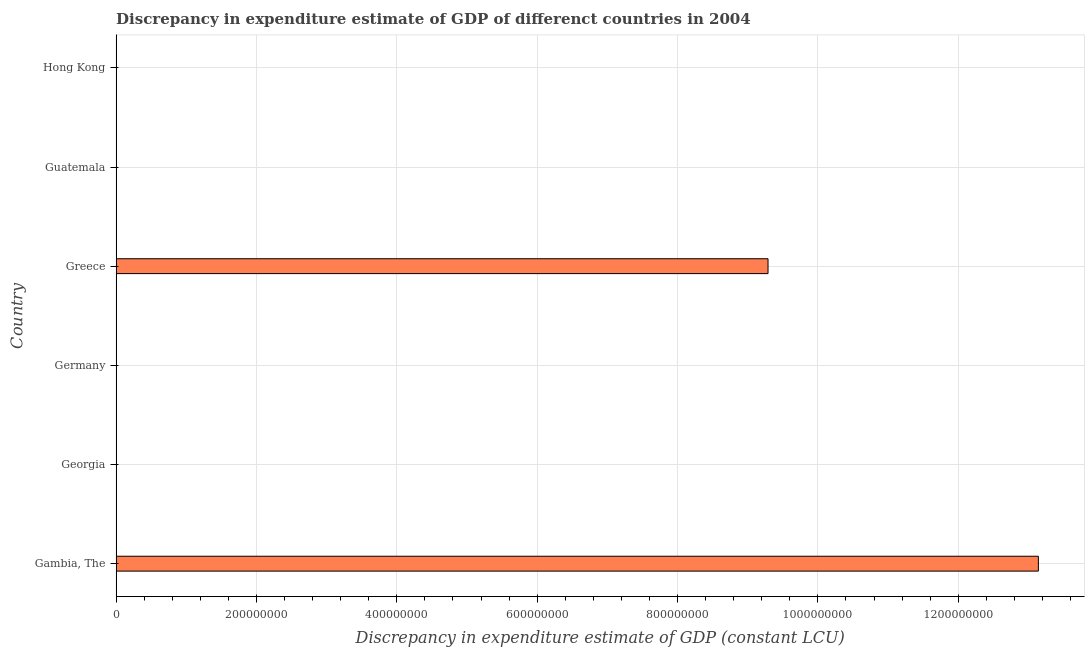Does the graph contain any zero values?
Provide a succinct answer. Yes. What is the title of the graph?
Offer a terse response. Discrepancy in expenditure estimate of GDP of differenct countries in 2004. What is the label or title of the X-axis?
Keep it short and to the point. Discrepancy in expenditure estimate of GDP (constant LCU). What is the label or title of the Y-axis?
Your answer should be very brief. Country. What is the discrepancy in expenditure estimate of gdp in Hong Kong?
Your answer should be very brief. 0. Across all countries, what is the maximum discrepancy in expenditure estimate of gdp?
Make the answer very short. 1.31e+09. In which country was the discrepancy in expenditure estimate of gdp maximum?
Your response must be concise. Gambia, The. What is the sum of the discrepancy in expenditure estimate of gdp?
Your answer should be very brief. 2.24e+09. What is the difference between the discrepancy in expenditure estimate of gdp in Gambia, The and Greece?
Give a very brief answer. 3.85e+08. What is the average discrepancy in expenditure estimate of gdp per country?
Give a very brief answer. 3.74e+08. What is the median discrepancy in expenditure estimate of gdp?
Make the answer very short. 0. What is the ratio of the discrepancy in expenditure estimate of gdp in Gambia, The to that in Greece?
Offer a terse response. 1.42. What is the difference between the highest and the lowest discrepancy in expenditure estimate of gdp?
Keep it short and to the point. 1.31e+09. In how many countries, is the discrepancy in expenditure estimate of gdp greater than the average discrepancy in expenditure estimate of gdp taken over all countries?
Your response must be concise. 2. Are all the bars in the graph horizontal?
Ensure brevity in your answer.  Yes. What is the Discrepancy in expenditure estimate of GDP (constant LCU) of Gambia, The?
Offer a very short reply. 1.31e+09. What is the Discrepancy in expenditure estimate of GDP (constant LCU) in Greece?
Offer a very short reply. 9.29e+08. What is the Discrepancy in expenditure estimate of GDP (constant LCU) of Guatemala?
Make the answer very short. 0. What is the difference between the Discrepancy in expenditure estimate of GDP (constant LCU) in Gambia, The and Greece?
Offer a very short reply. 3.85e+08. What is the ratio of the Discrepancy in expenditure estimate of GDP (constant LCU) in Gambia, The to that in Greece?
Ensure brevity in your answer.  1.42. 